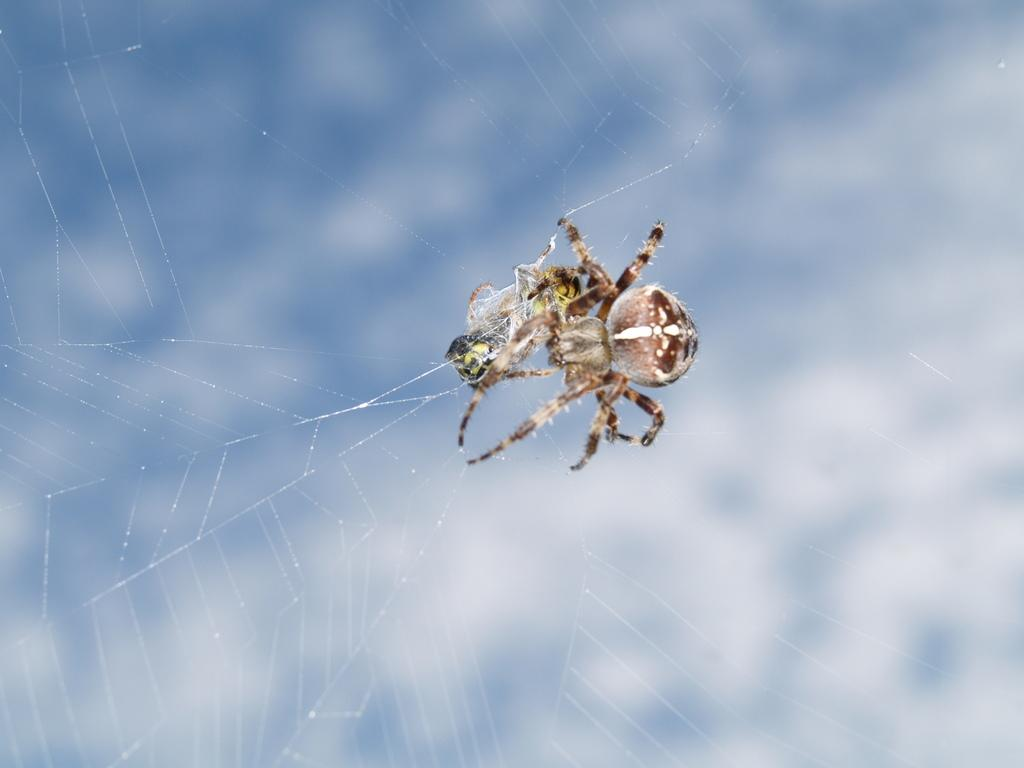What is the main subject of the image? There is a spider in the image. Where is the spider located? The spider is on a web. What type of silver can be seen in the image? There is no silver present in the image; it features a spider on a web. What kind of picture is displayed in the store in the image? There is no picture or store present in the image; it only shows a spider on a web. 